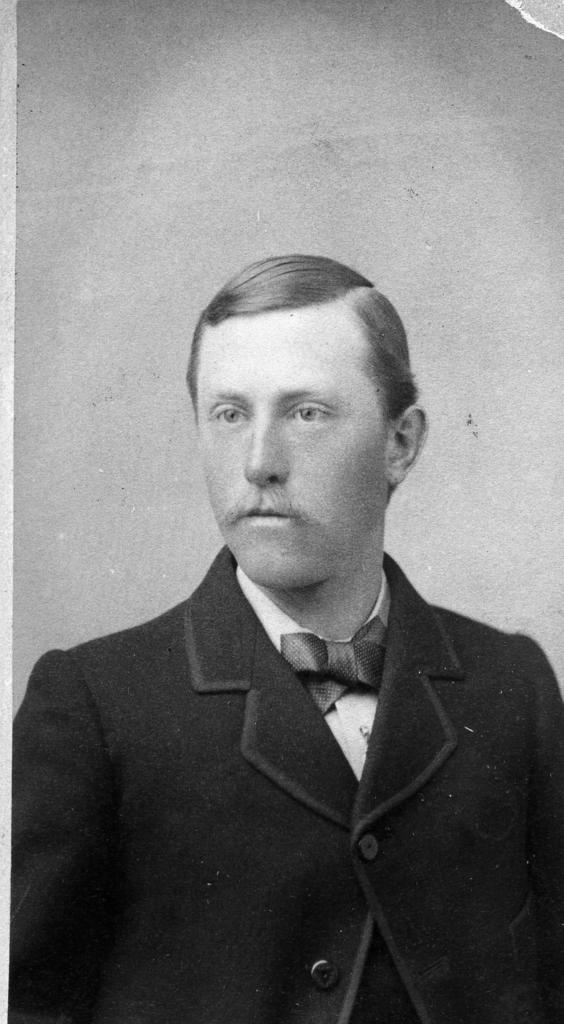What is the color scheme of the image? The image is black and white. Can you describe the main subject in the image? There is a person in the image. What type of clothing is the person wearing? The person is wearing a blazer. How many cows can be seen in the image? There are no cows present in the image. What type of tool is the person holding in the image? The image does not show the person holding any tool, such as a wrench. 